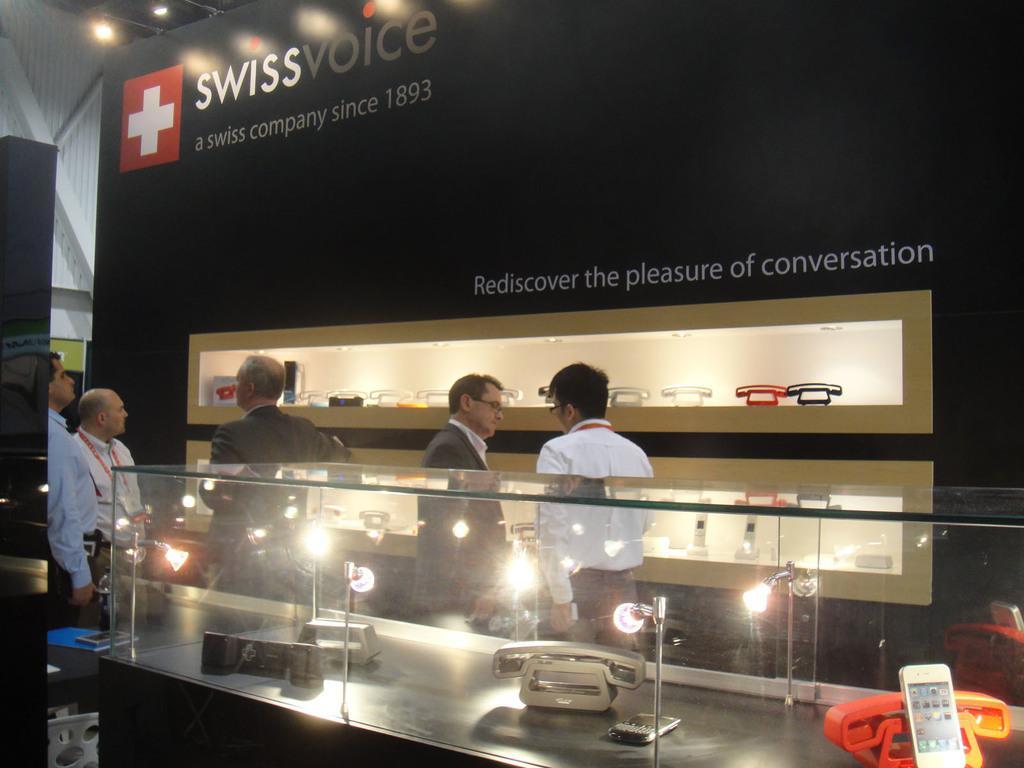Could you give a brief overview of what you see in this image? In this image there is a glass box, in that box there are mobiles and lights, in the background there are people standing and there is a board, on that board there is some text and there are mobiles. 